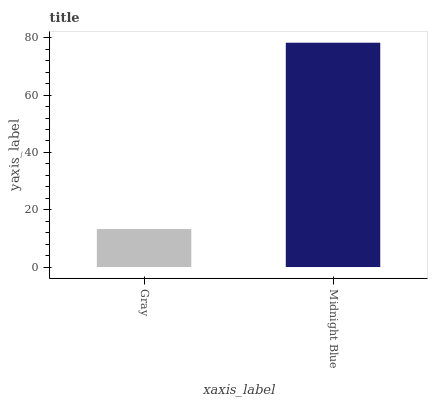Is Gray the minimum?
Answer yes or no. Yes. Is Midnight Blue the maximum?
Answer yes or no. Yes. Is Midnight Blue the minimum?
Answer yes or no. No. Is Midnight Blue greater than Gray?
Answer yes or no. Yes. Is Gray less than Midnight Blue?
Answer yes or no. Yes. Is Gray greater than Midnight Blue?
Answer yes or no. No. Is Midnight Blue less than Gray?
Answer yes or no. No. Is Midnight Blue the high median?
Answer yes or no. Yes. Is Gray the low median?
Answer yes or no. Yes. Is Gray the high median?
Answer yes or no. No. Is Midnight Blue the low median?
Answer yes or no. No. 